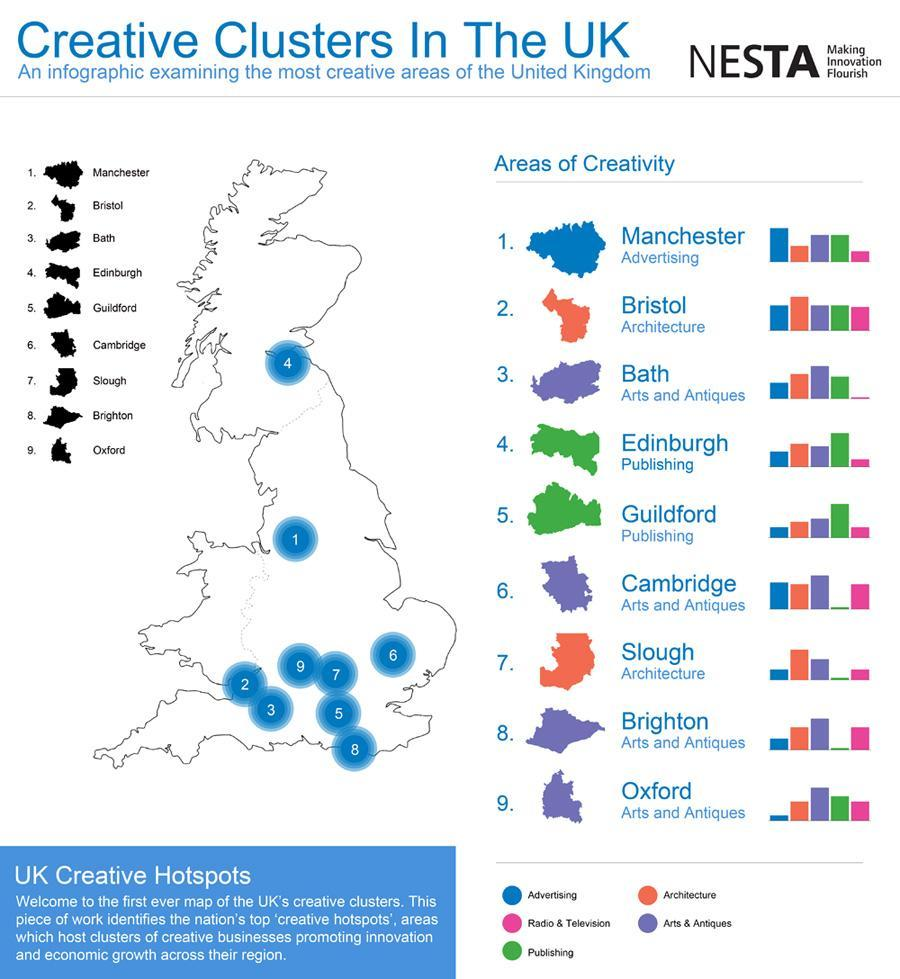In which creative area, the Oxford City is famous for?
Answer the question with a short phrase. Arts and Antiques Which cities in UK served as the hotspot for Architecture? Bristol, Slough Which cities in UK served as the hotspot for publishing? Edinburgh, Guildford In which creative area, the Cambridge City is famous for? Arts and Antiques Which city in UK is the hotspot for advertising? Manchester 